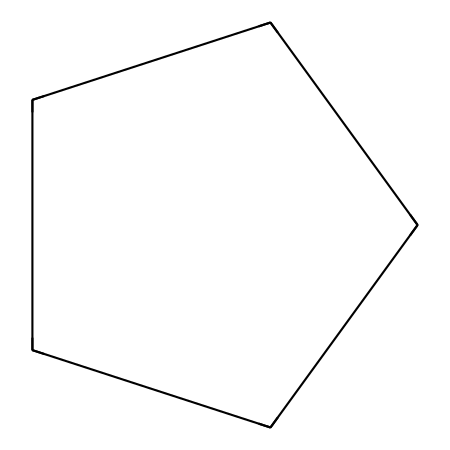What is the molecular formula of cyclopentane? Cyclopentane contains five carbon atoms and its molecular formula can be determined by counting the carbon (C) and hydrogen (H) atoms in the structure. The general formula for cycloalkanes is CnH2n, where n is the number of carbon atoms. For cyclopentane (n=5), the molecular formula is C5H10.
Answer: C5H10 How many carbon atoms are present in cyclopentane? By examining the SMILES representation, each "C" represents a carbon atom. Counting the "C" in the structure reveals there are five carbon atoms in cyclopentane.
Answer: 5 What type of molecular structure does cyclopentane have? Cyclopentane is classified as a cycloalkane due to its closed-ring structure composed entirely of carbon atoms. Cycloalkanes are characterized by their cyclic arrangement, which is evident in the given structure.
Answer: cyclic What is the degree of saturation of cyclopentane? The degree of saturation can be calculated by the formula (2C + 2 + N - H) / 2, where C is the number of carbons, N is the number of nitrogens (zero for cyclopentane), and H is the number of hydrogens. For cyclopentane: (2*5 + 2 - 10) / 2 = 0, indicating it is fully saturated with no double or triple bonds.
Answer: 0 Are there any double bonds in cyclopentane? Examining the SMILES representation and structural characteristics shows that all carbon atoms are connected by single bonds, characteristic of saturated hydrocarbons, confirming there are no double bonds present.
Answer: no What is the main use of cyclopentane in camera cleaning solutions? Cyclopentane is utilized in camera cleaning solutions primarily due to its low surface tension and ability to effectively dissolve oily residues and dirt, facilitating better cleaning performance.
Answer: cleaning agent 